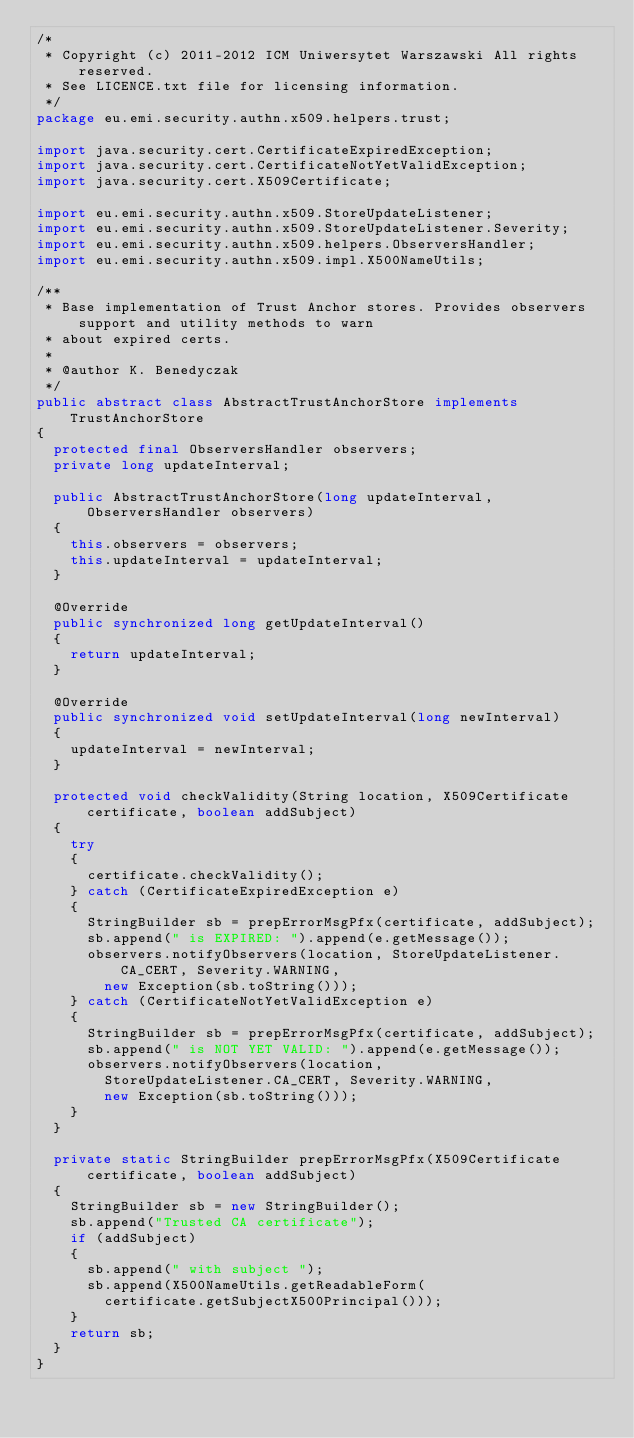<code> <loc_0><loc_0><loc_500><loc_500><_Java_>/*
 * Copyright (c) 2011-2012 ICM Uniwersytet Warszawski All rights reserved.
 * See LICENCE.txt file for licensing information.
 */
package eu.emi.security.authn.x509.helpers.trust;

import java.security.cert.CertificateExpiredException;
import java.security.cert.CertificateNotYetValidException;
import java.security.cert.X509Certificate;

import eu.emi.security.authn.x509.StoreUpdateListener;
import eu.emi.security.authn.x509.StoreUpdateListener.Severity;
import eu.emi.security.authn.x509.helpers.ObserversHandler;
import eu.emi.security.authn.x509.impl.X500NameUtils;

/**
 * Base implementation of Trust Anchor stores. Provides observers support and utility methods to warn
 * about expired certs.
 *  
 * @author K. Benedyczak
 */
public abstract class AbstractTrustAnchorStore implements TrustAnchorStore 
{
	protected final ObserversHandler observers;
	private long updateInterval;
	
	public AbstractTrustAnchorStore(long updateInterval, ObserversHandler observers)
	{
		this.observers = observers;
		this.updateInterval = updateInterval;
	}
	
	@Override
	public synchronized long getUpdateInterval()
	{
		return updateInterval;
	}
	
	@Override
	public synchronized void setUpdateInterval(long newInterval)
	{
		updateInterval = newInterval;
	}
	
	protected void checkValidity(String location, X509Certificate certificate, boolean addSubject)
	{
		try
		{
			certificate.checkValidity();
		} catch (CertificateExpiredException e)
		{
			StringBuilder sb = prepErrorMsgPfx(certificate, addSubject);
			sb.append(" is EXPIRED: ").append(e.getMessage());
			observers.notifyObservers(location, StoreUpdateListener.CA_CERT, Severity.WARNING, 
				new Exception(sb.toString()));
		} catch (CertificateNotYetValidException e)
		{
			StringBuilder sb = prepErrorMsgPfx(certificate, addSubject);
			sb.append(" is NOT YET VALID: ").append(e.getMessage());
			observers.notifyObservers(location, 
				StoreUpdateListener.CA_CERT, Severity.WARNING, 
				new Exception(sb.toString()));
		} 
	}
	
	private static StringBuilder prepErrorMsgPfx(X509Certificate certificate, boolean addSubject)
	{
		StringBuilder sb = new StringBuilder();
		sb.append("Trusted CA certificate");
		if (addSubject)
		{
			sb.append(" with subject ");
			sb.append(X500NameUtils.getReadableForm(
				certificate.getSubjectX500Principal()));
		}
		return sb;
	}
}
</code> 